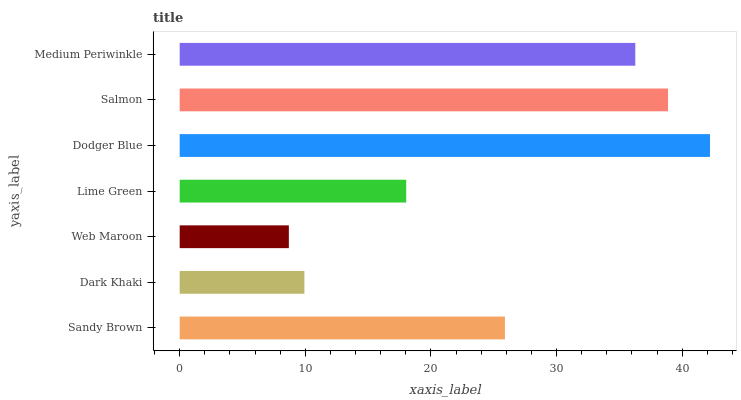Is Web Maroon the minimum?
Answer yes or no. Yes. Is Dodger Blue the maximum?
Answer yes or no. Yes. Is Dark Khaki the minimum?
Answer yes or no. No. Is Dark Khaki the maximum?
Answer yes or no. No. Is Sandy Brown greater than Dark Khaki?
Answer yes or no. Yes. Is Dark Khaki less than Sandy Brown?
Answer yes or no. Yes. Is Dark Khaki greater than Sandy Brown?
Answer yes or no. No. Is Sandy Brown less than Dark Khaki?
Answer yes or no. No. Is Sandy Brown the high median?
Answer yes or no. Yes. Is Sandy Brown the low median?
Answer yes or no. Yes. Is Dark Khaki the high median?
Answer yes or no. No. Is Lime Green the low median?
Answer yes or no. No. 